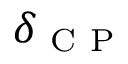Convert formula to latex. <formula><loc_0><loc_0><loc_500><loc_500>\delta _ { C P }</formula> 